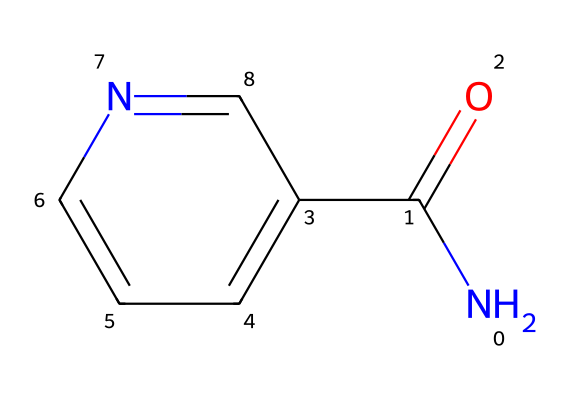How many nitrogen atoms are in this structure? The chemical structure includes a single nitrogen atom (N). By analyzing the SMILES representation, we can confirm that there is only one 'N' present in the structure.
Answer: 1 What is the total number of carbon atoms in this compound? The structure contains 6 carbon atoms, which can be counted from the 'c' and 'C' symbols in the SMILES representation. Each 'C' indicates a carbon atom, and 'c' denotes aromatic carbon atoms, which together total to 6.
Answer: 6 What is the functional group present in this chemical? The functional group is amide, indicated by the 'NC(=O)' part of the SMILES. This indicates the presence of a nitrogen atom bonded to a carbonyl (C=O) group.
Answer: amide Is this compound hydrophilic or hydrophobic? Niacinamide is hydrophilic due to the presence of polar functional groups such as amide and no long hydrophobic carbon chains. This makes it soluble in water.
Answer: hydrophilic What effect does this compound have on skin? Niacinamide is known for its skin-brightening effects, as it helps to reduce dark spots and improve skin tone. This is recognized as a common property attributed to its mechanism of action in skincare.
Answer: brightening How many double bonds does this structure contain? The chemical structure includes 1 double bond, which can be identified between the carbon (C) and oxygen (O) in the carbonyl (C=O) group.
Answer: 1 What type of skincare product commonly contains this ingredient? Niacinamide is commonly found in facial serums, which are designed for targeted skincare treatments. This association can be established through the ingredient's popularity in cosmetic formulations.
Answer: facial serums 